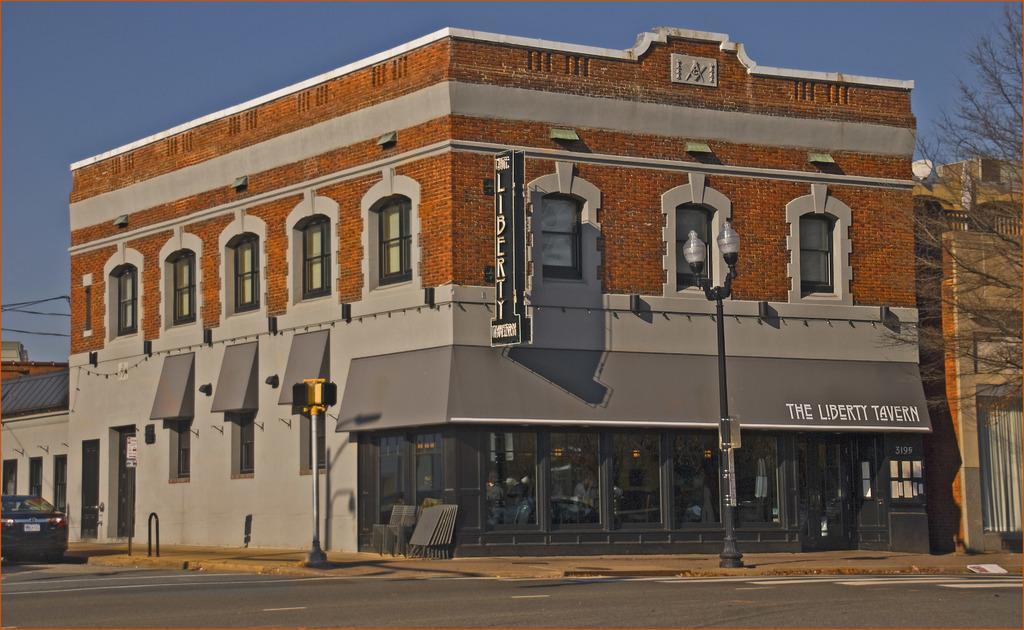How would you summarize this image in a sentence or two? In this picture I can observe a building in the middle of the picture. On the right side there is a pole to which two lights are fixed. In the background there is sky. 